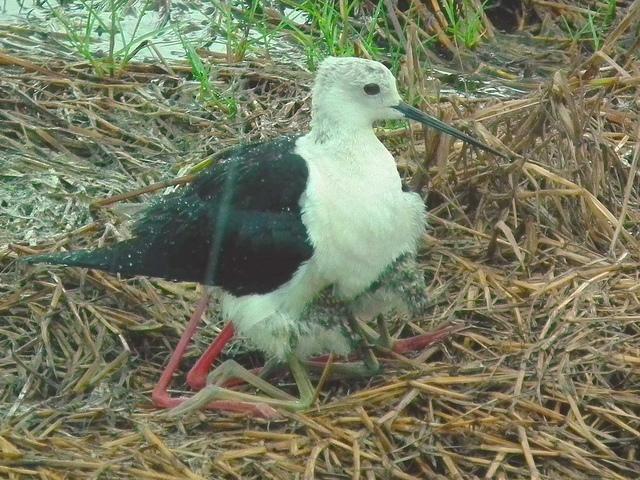What color is the bird?
Write a very short answer. White and black. Is the bird eating?
Answer briefly. No. What type of animal is this?
Give a very brief answer. Bird. What type of birds are these?
Short answer required. Piper. What color are the bird's legs?
Write a very short answer. Red. Is this bird domesticated?
Answer briefly. No. 